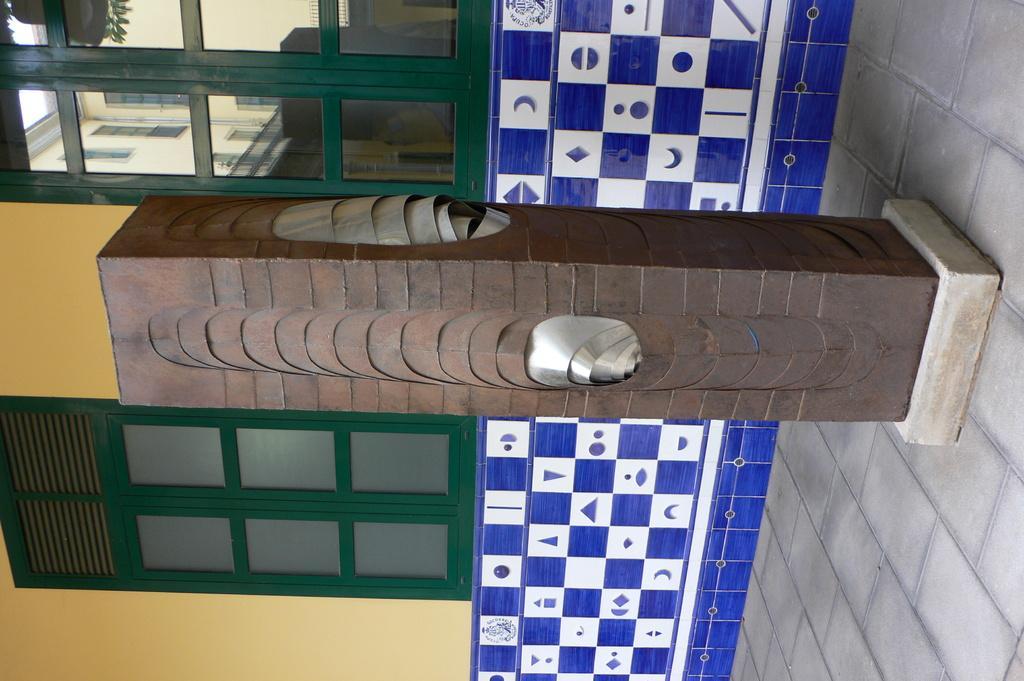Please provide a concise description of this image. This is well with the windows made of glass, this is pillar. 